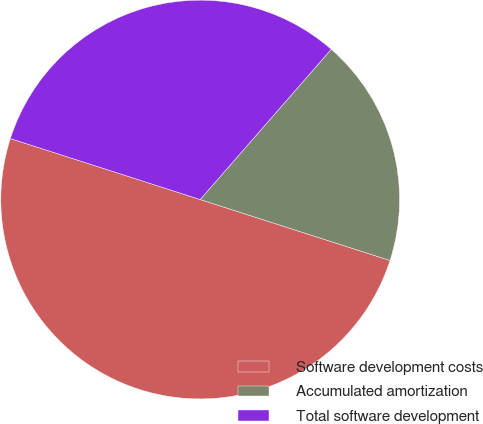Convert chart to OTSL. <chart><loc_0><loc_0><loc_500><loc_500><pie_chart><fcel>Software development costs<fcel>Accumulated amortization<fcel>Total software development<nl><fcel>50.0%<fcel>18.53%<fcel>31.47%<nl></chart> 